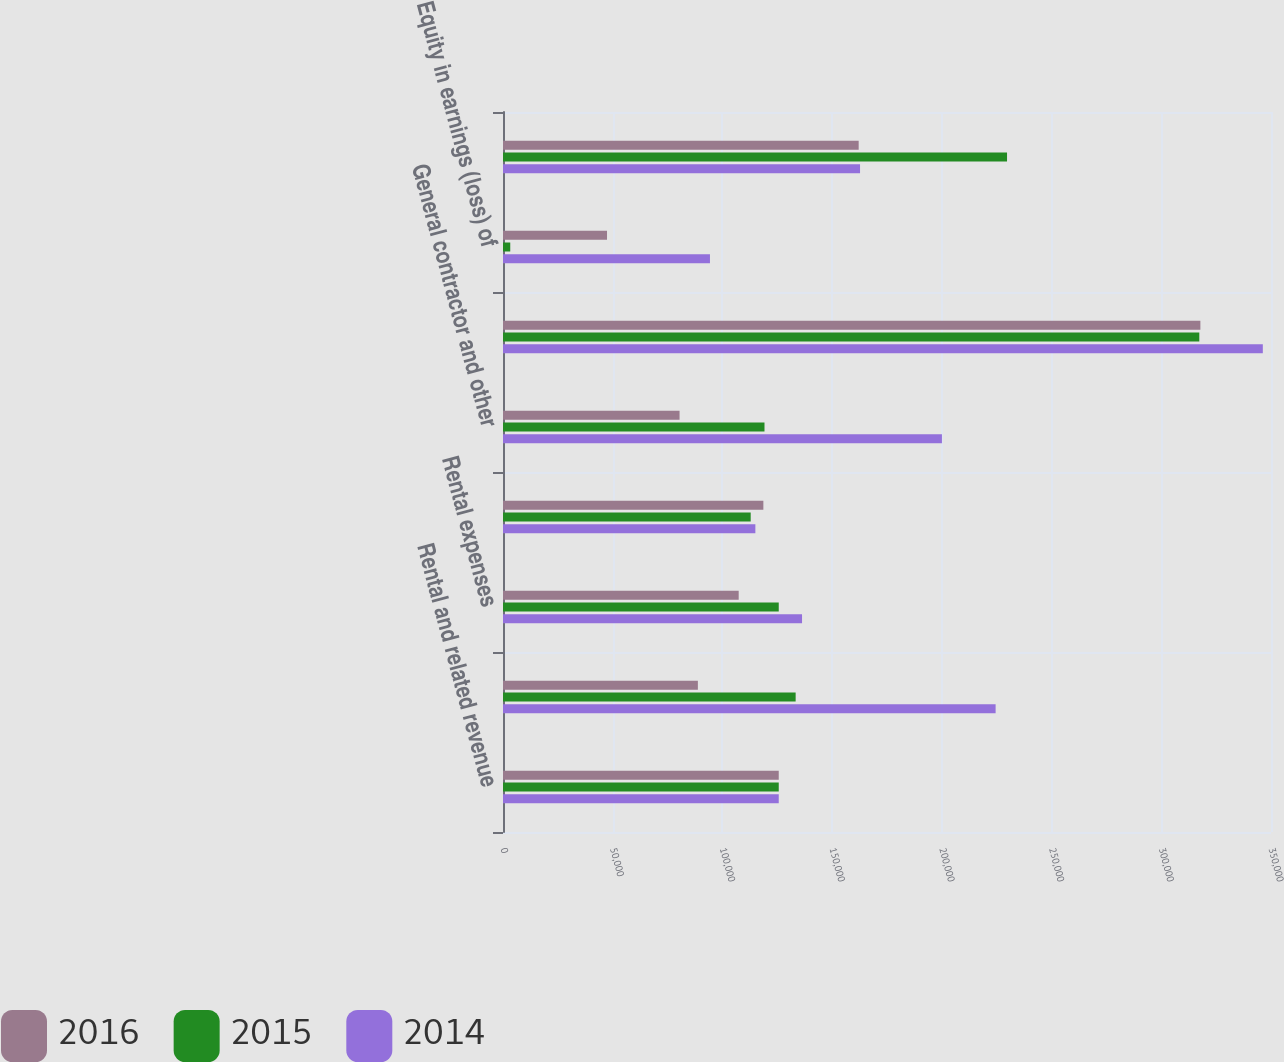<chart> <loc_0><loc_0><loc_500><loc_500><stacked_bar_chart><ecel><fcel>Rental and related revenue<fcel>General contractor and service<fcel>Rental expenses<fcel>Real estate taxes<fcel>General contractor and other<fcel>Depreciation and amortization<fcel>Equity in earnings (loss) of<fcel>Gain on sale of properties<nl><fcel>2016<fcel>125666<fcel>88810<fcel>107410<fcel>118654<fcel>80467<fcel>317818<fcel>47403<fcel>162093<nl><fcel>2015<fcel>125666<fcel>133367<fcel>125666<fcel>112879<fcel>119170<fcel>317329<fcel>3304<fcel>229702<nl><fcel>2014<fcel>125666<fcel>224500<fcel>136278<fcel>115013<fcel>200031<fcel>346275<fcel>94317<fcel>162715<nl></chart> 